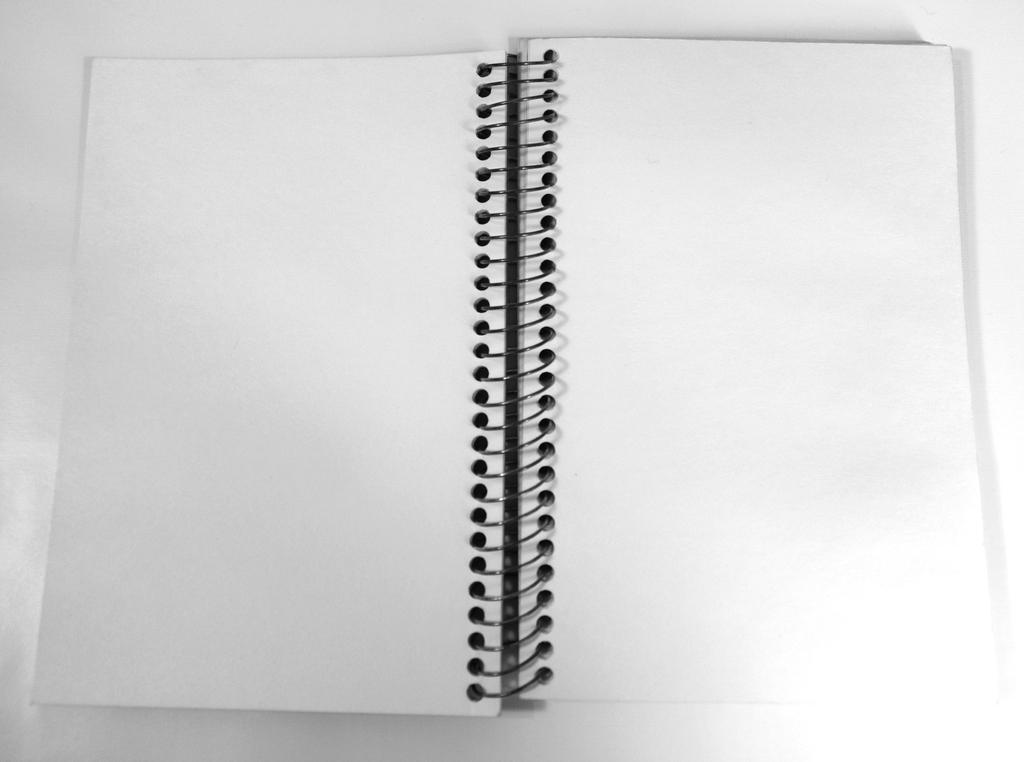What is the main object in the image? There is an open book in the image. Where is the open book located? The open book is placed on a table. What type of cake is being served on the table next to the open book? There is no cake present in the image; it only features an open book placed on a table. 